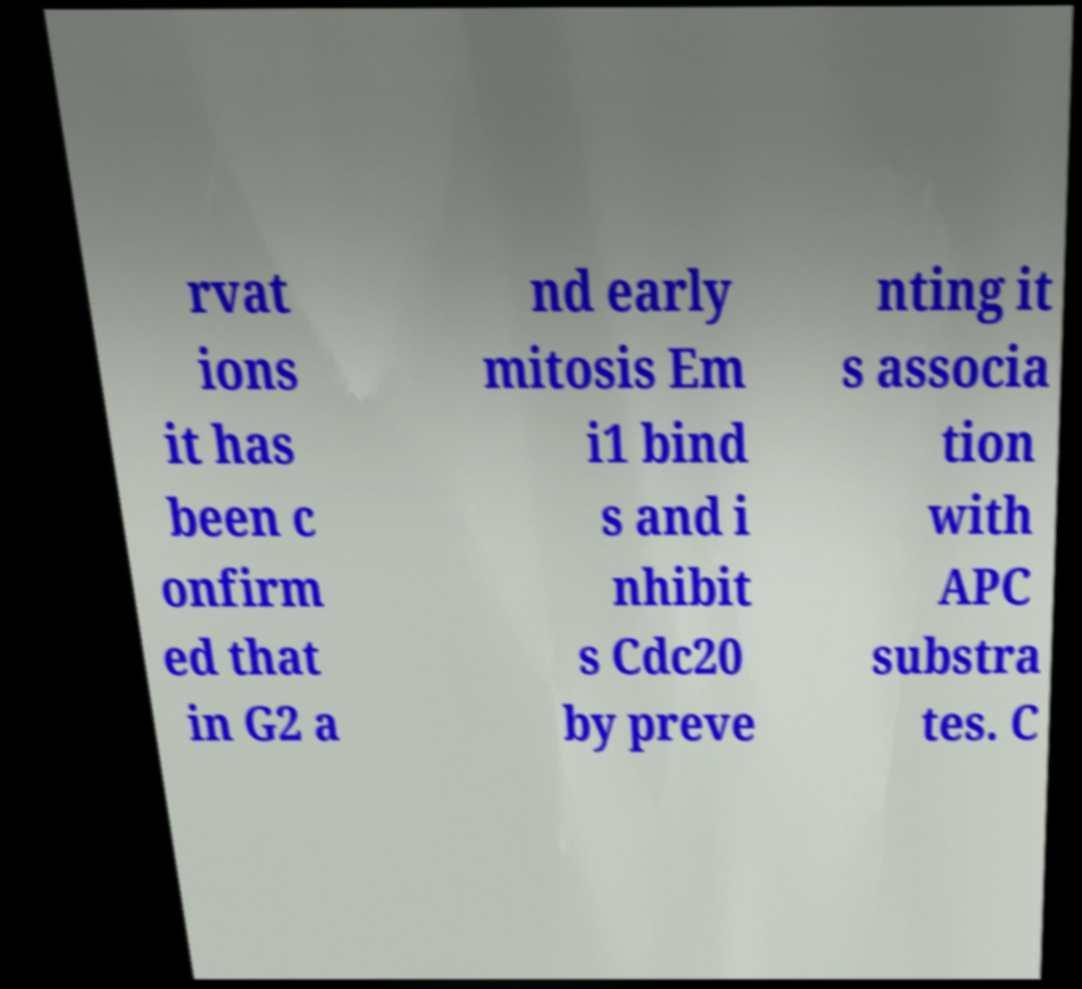What messages or text are displayed in this image? I need them in a readable, typed format. rvat ions it has been c onfirm ed that in G2 a nd early mitosis Em i1 bind s and i nhibit s Cdc20 by preve nting it s associa tion with APC substra tes. C 